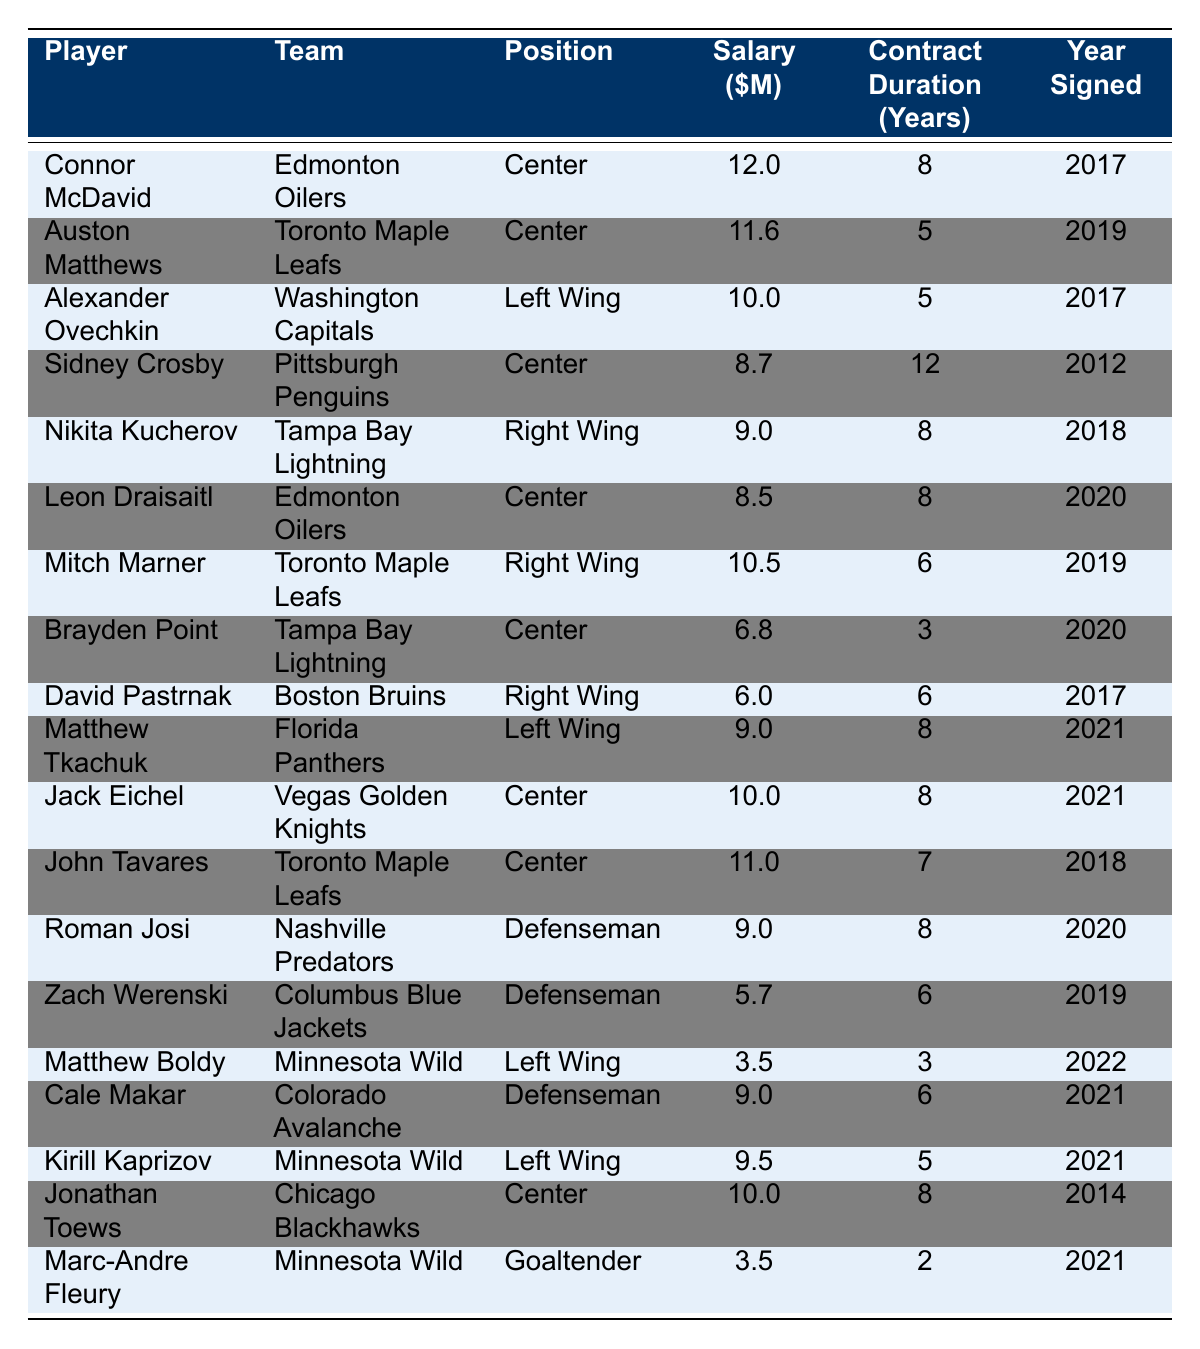What is the salary of Connor McDavid? The table lists Connor McDavid’s salary directly as $12,000,000.
Answer: $12,000,000 How many years is Sidney Crosby's contract? Sidney Crosby’s contract duration is listed in the table as 12 years.
Answer: 12 years Which player has the highest salary? The table shows that Connor McDavid has the highest salary at $12,000,000.
Answer: Connor McDavid What is the average salary of all players listed in the table? To find the average, sum all the salaries: (12 + 11.6 + 10 + 8.7 + 9 + 8.5 + 10.5 + 6.8 + 6 + 9 + 10 + 11 + 9 + 5.7 + 3.5 + 9 + 9.5 + 10 + 3.5) =  109.3 million, and divide by the number of players (20): 109.3/20 = 5.465 million.
Answer: $5.465 million Is there any player with a contract duration of 2 years? The table indicates that Marc-Andre Fleury has a contract duration of 2 years.
Answer: Yes Which team has the player with the lowest salary? The lowest salary is $3,500,000 belonging to Matthew Boldy and Marc-Andre Fleury, who both play for Minnesota Wild.
Answer: Minnesota Wild How many players have a contract duration of 8 years? The table shows that there are 5 players (McDavid, Kucherov, Draisaitl, Tkachuk, Eichel, Toews) with a contract duration of 8 years.
Answer: 5 players What is the total sum of salaries for players signed in 2021? The players signed in 2021 are Matthew Tkachuk, Jack Eichel, Cale Makar, Kirill Kaprizov, and Marc-Andre Fleury. Their salaries are $9,000,000 + $10,000,000 + $9,000,000 + $9,500,000 + $3,500,000 = $40,000,000.
Answer: $40,000,000 How many forwards are listed in this table? The table categorizes players into positions: 10 forwards (Centers, Left Wings, Right Wings) are identified.
Answer: 10 forwards What is the median contract duration among these players? To find the median, list the contract durations in order: 2, 3, 5, 5, 6, 6, 6, 7, 8, 8, 8, 8, 8, 8, 12; There are 20 data points, the median is the average of the 10th and 11th values: (8+8)/2 = 8.
Answer: 8 years Which position has the highest average salary? Calculate average salaries for each position. Forwards (~$8.68 million), Defensemen (~$7.99 million), and Goaltenders (~$3.5 million). Centers have the highest average salary, approximately $9.57 million.
Answer: Centers have the highest average salary 